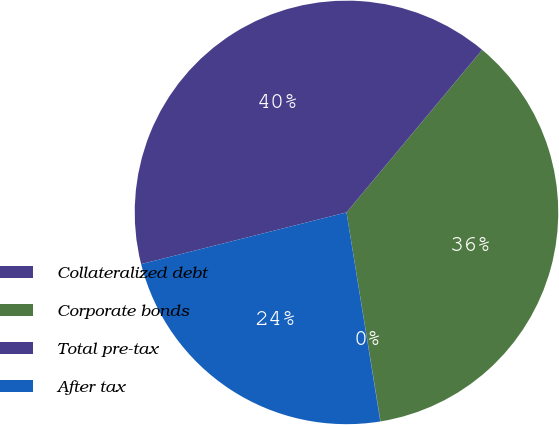Convert chart to OTSL. <chart><loc_0><loc_0><loc_500><loc_500><pie_chart><fcel>Collateralized debt<fcel>Corporate bonds<fcel>Total pre-tax<fcel>After tax<nl><fcel>0.02%<fcel>36.36%<fcel>39.99%<fcel>23.63%<nl></chart> 